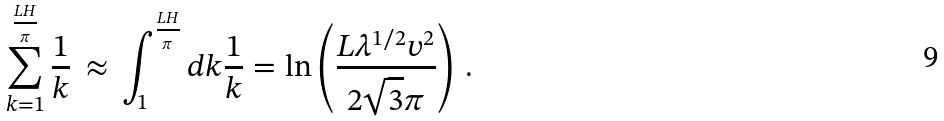<formula> <loc_0><loc_0><loc_500><loc_500>\sum _ { k = 1 } ^ { \frac { L H } { \pi } } \frac { 1 } { k } \, \approx \, \int _ { 1 } ^ { \frac { L H } { \pi } } d k \frac { 1 } { k } = \ln \left ( \frac { L \lambda ^ { 1 / 2 } v ^ { 2 } } { 2 \sqrt { 3 } \pi } \right ) \, .</formula> 